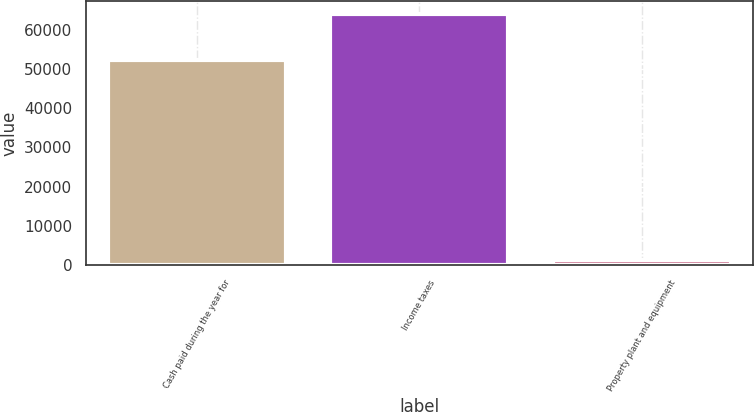Convert chart. <chart><loc_0><loc_0><loc_500><loc_500><bar_chart><fcel>Cash paid during the year for<fcel>Income taxes<fcel>Property plant and equipment<nl><fcel>52268<fcel>64092<fcel>1274<nl></chart> 